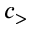<formula> <loc_0><loc_0><loc_500><loc_500>c _ { > }</formula> 